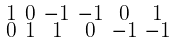Convert formula to latex. <formula><loc_0><loc_0><loc_500><loc_500>\begin{smallmatrix} 1 & 0 & - 1 & - 1 & 0 & 1 \\ 0 & 1 & 1 & 0 & - 1 & - 1 \end{smallmatrix}</formula> 